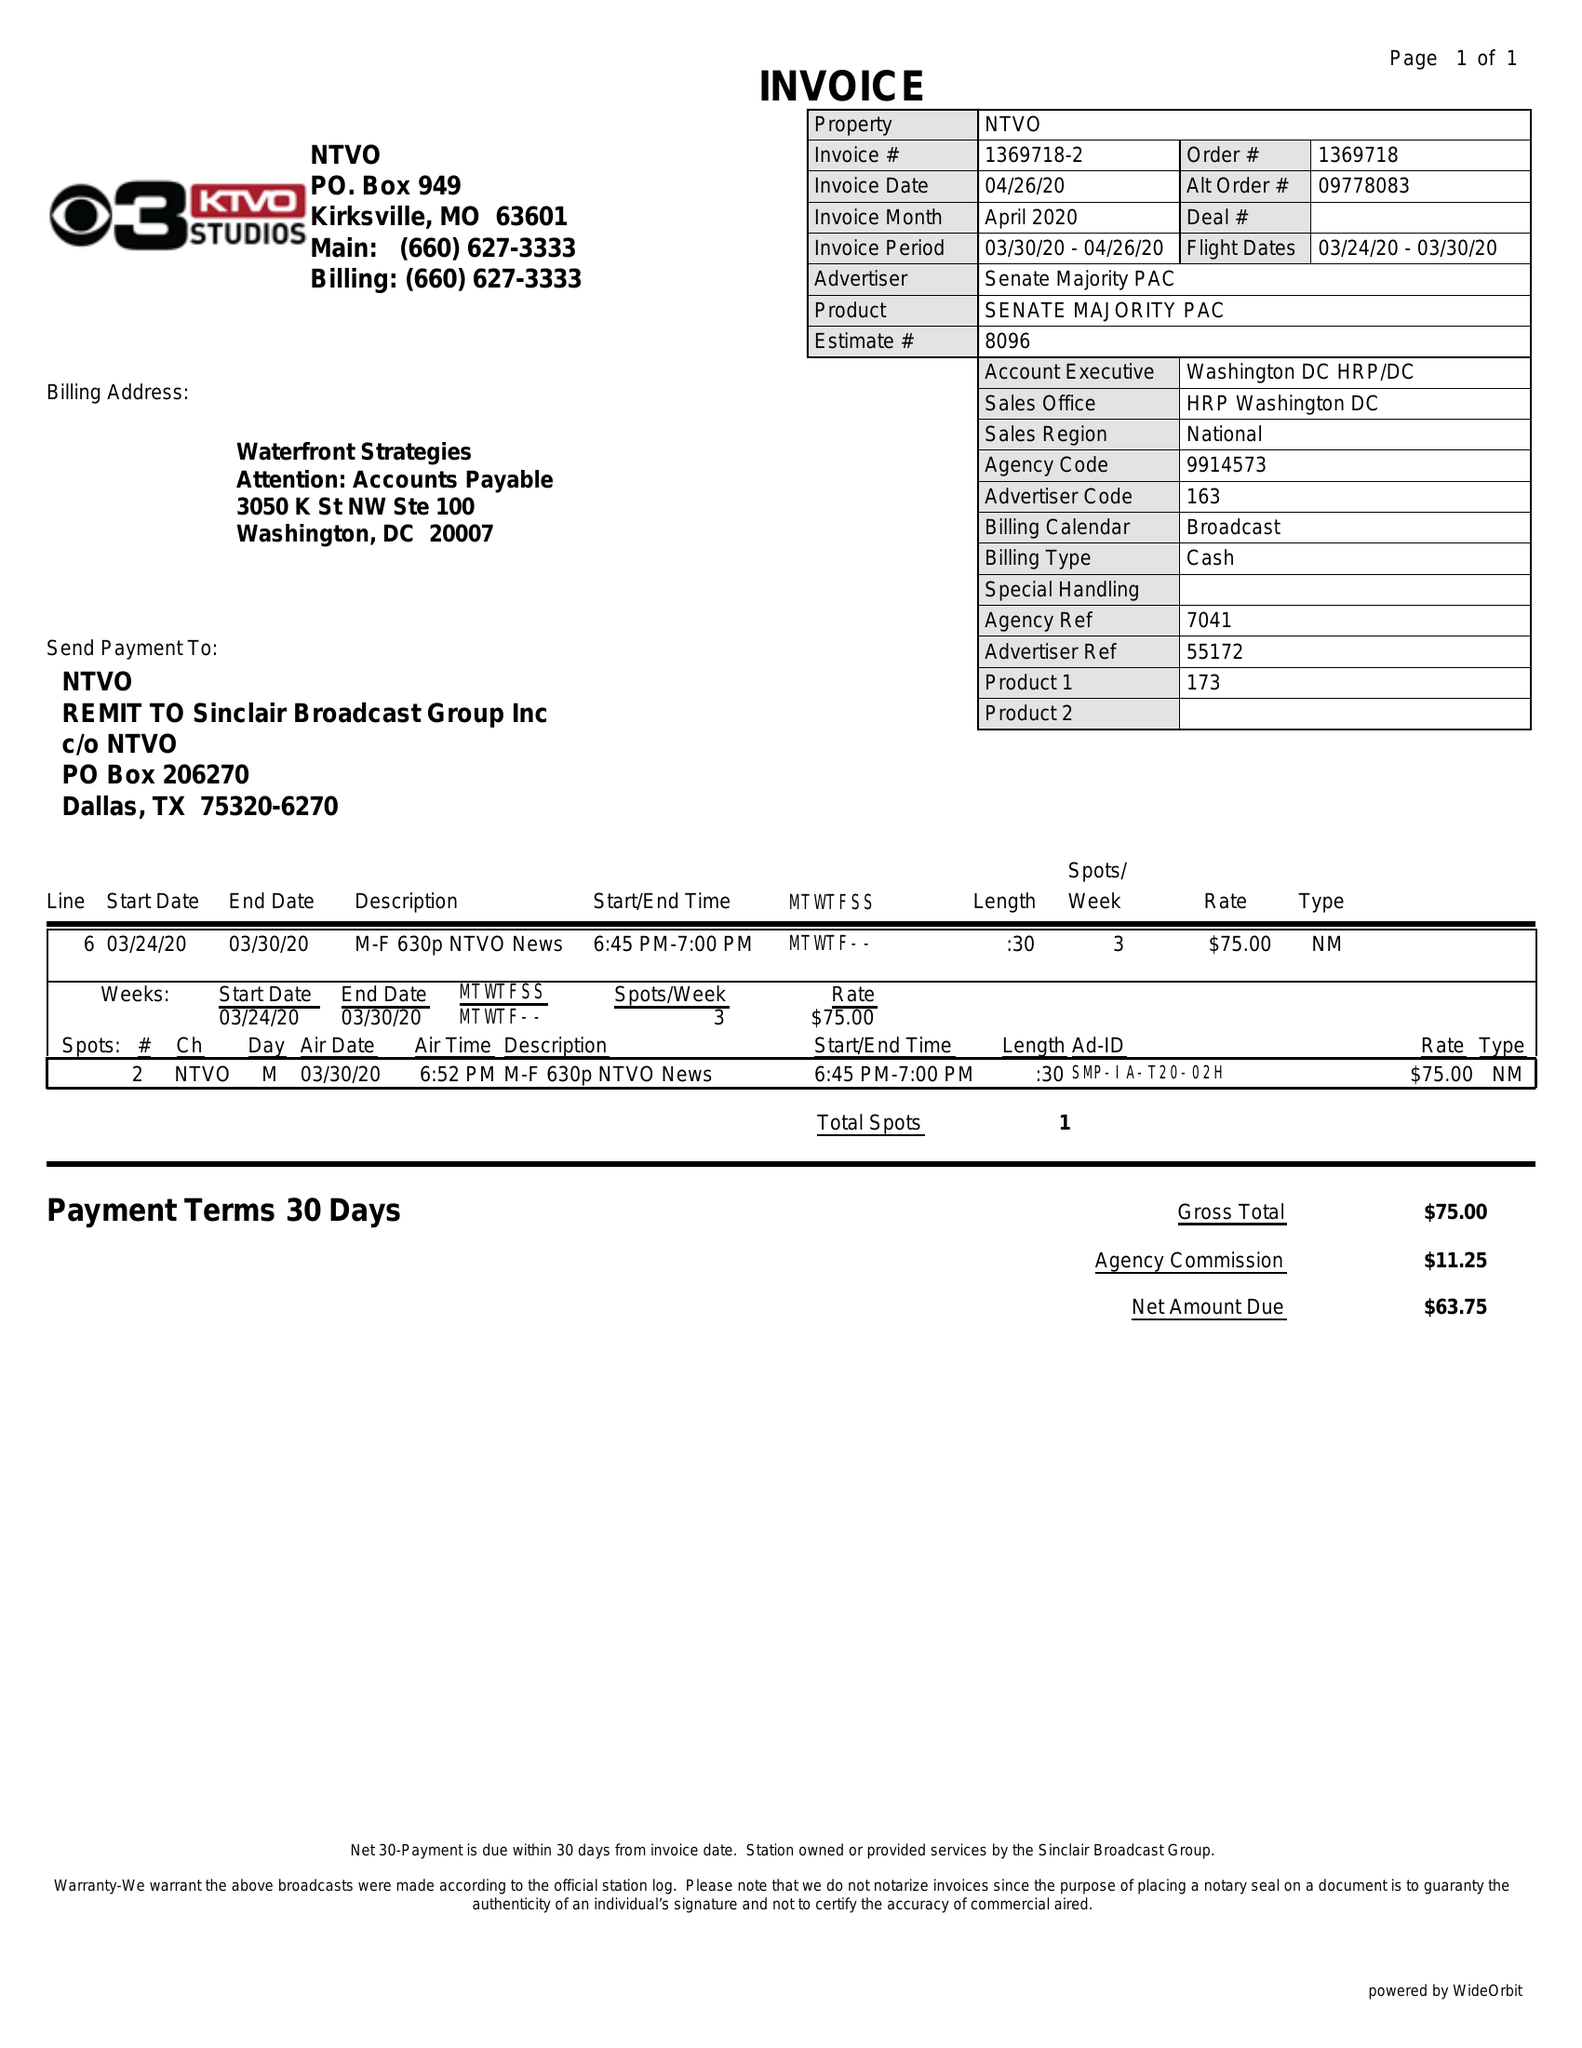What is the value for the advertiser?
Answer the question using a single word or phrase. SENATE MAJORITY PAC 